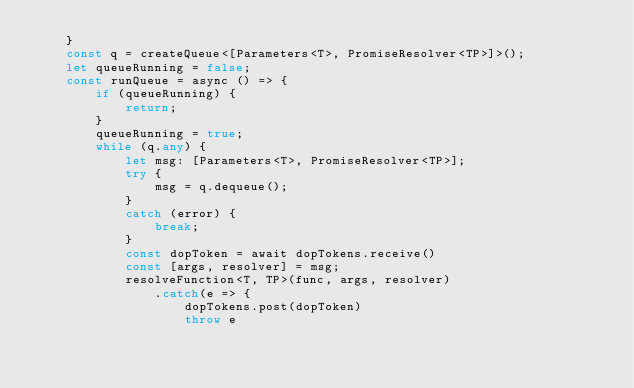<code> <loc_0><loc_0><loc_500><loc_500><_TypeScript_>    }
    const q = createQueue<[Parameters<T>, PromiseResolver<TP>]>();
    let queueRunning = false;
    const runQueue = async () => {
        if (queueRunning) {
            return;
        }
        queueRunning = true;
        while (q.any) {
            let msg: [Parameters<T>, PromiseResolver<TP>];
            try {
                msg = q.dequeue();
            }
            catch (error) {
                break;
            }
            const dopToken = await dopTokens.receive()
            const [args, resolver] = msg;
            resolveFunction<T, TP>(func, args, resolver)
                .catch(e => {
                    dopTokens.post(dopToken)
                    throw e</code> 